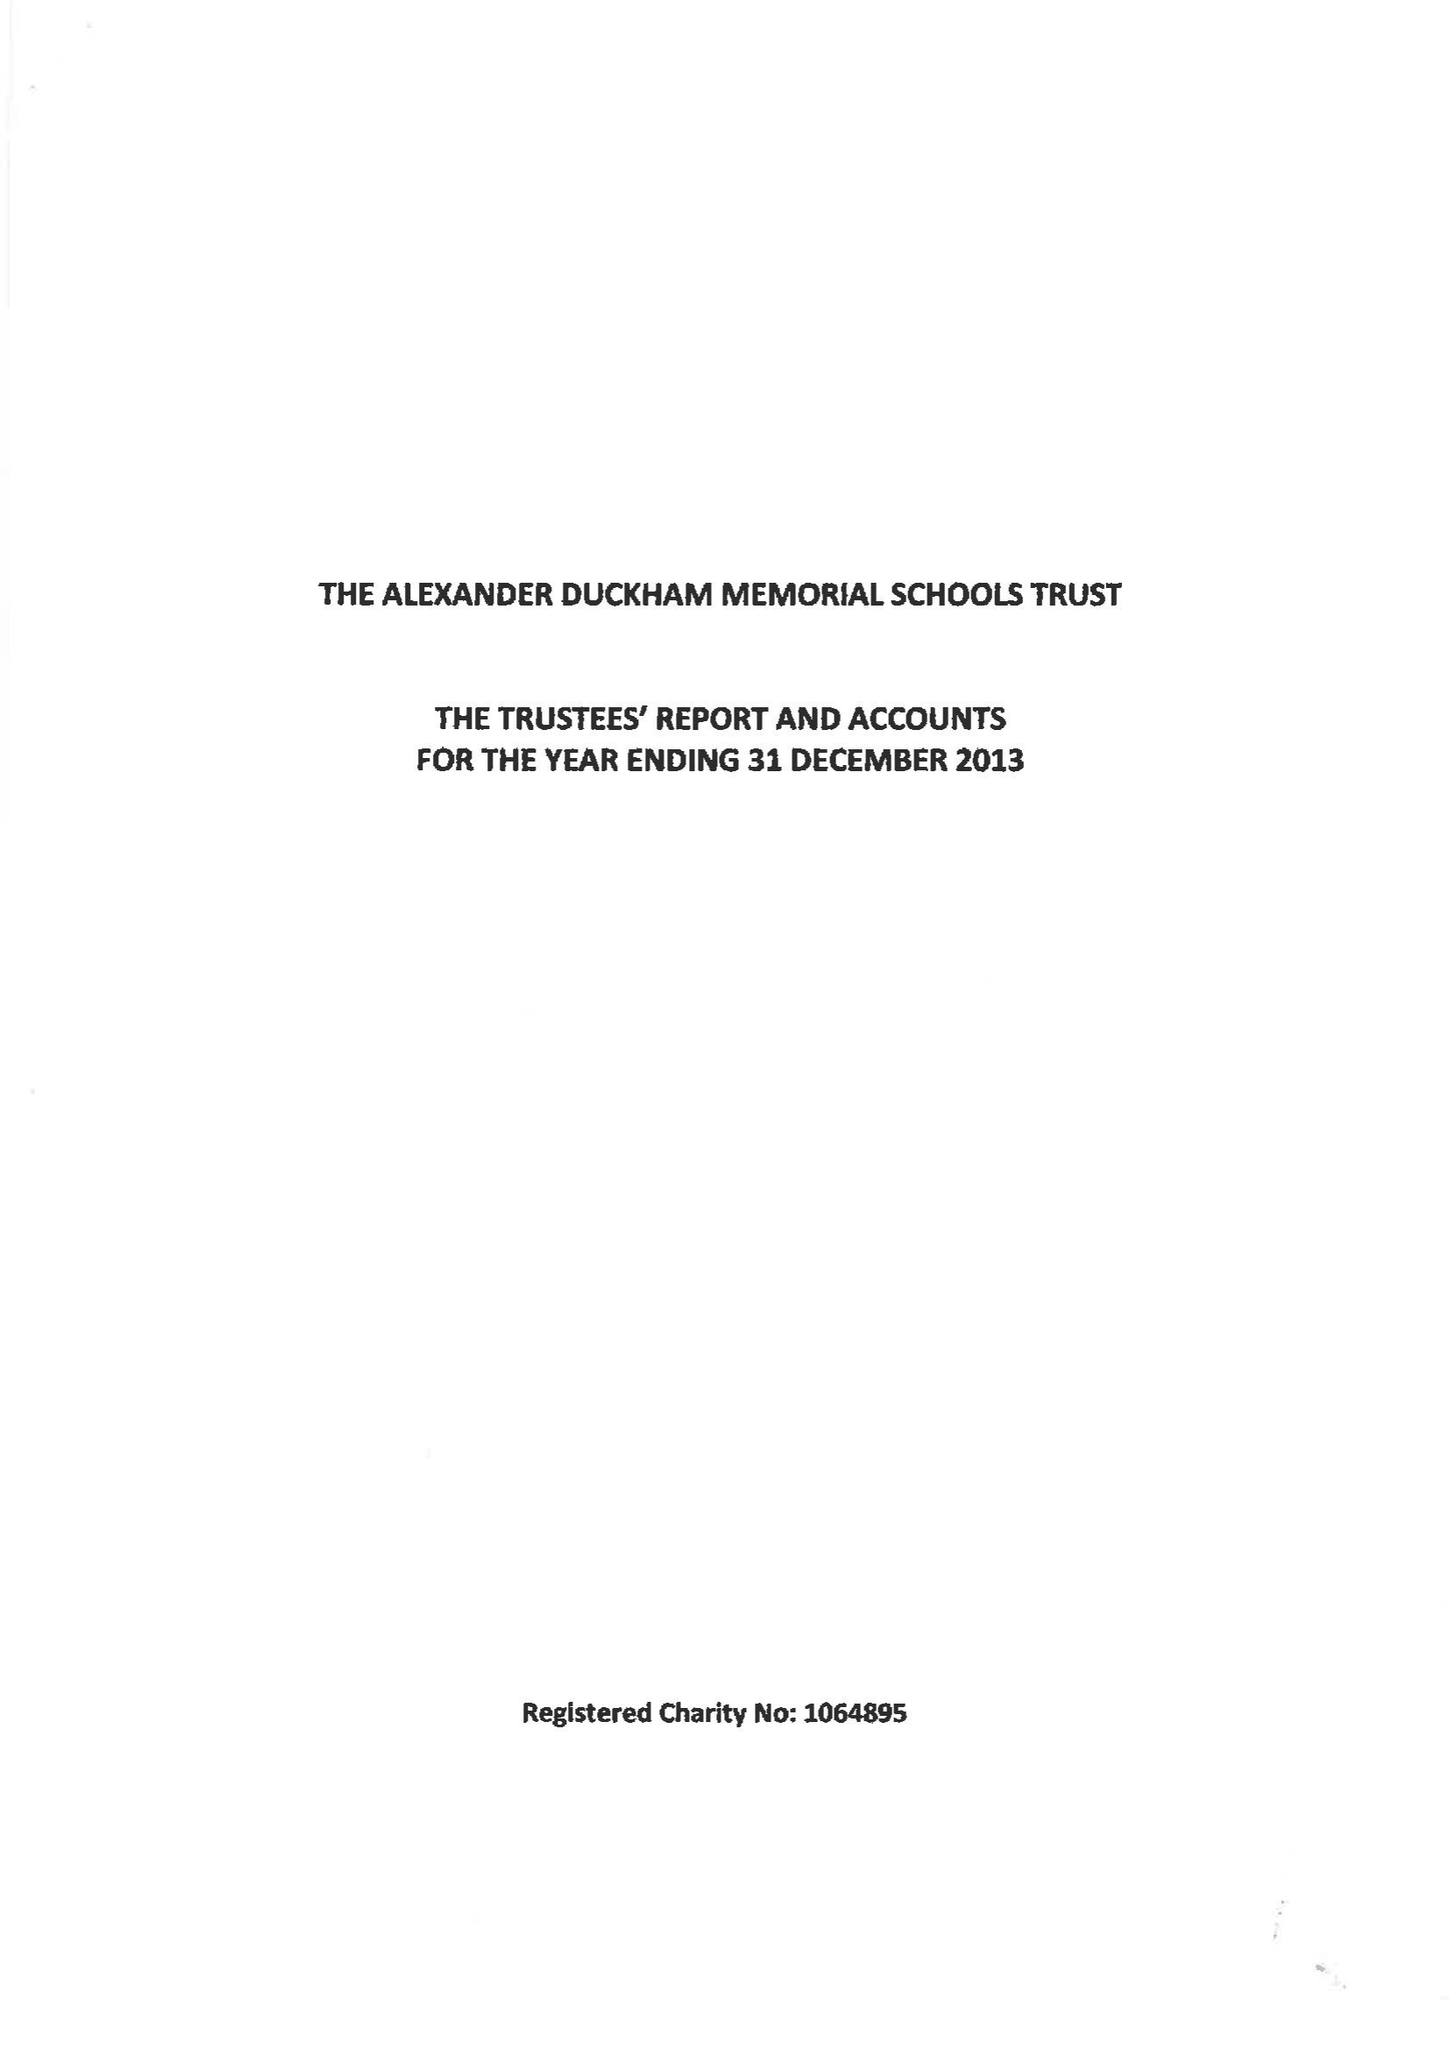What is the value for the income_annually_in_british_pounds?
Answer the question using a single word or phrase. 82427.00 